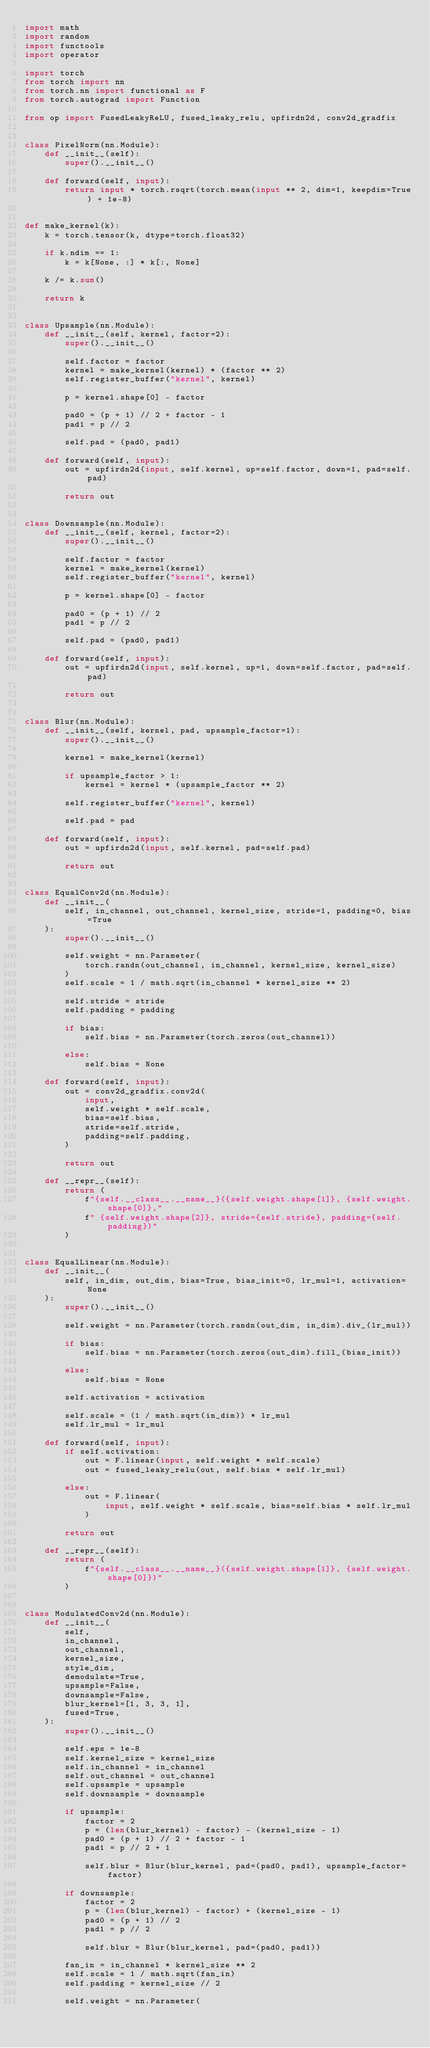<code> <loc_0><loc_0><loc_500><loc_500><_Python_>import math
import random
import functools
import operator

import torch
from torch import nn
from torch.nn import functional as F
from torch.autograd import Function

from op import FusedLeakyReLU, fused_leaky_relu, upfirdn2d, conv2d_gradfix


class PixelNorm(nn.Module):
    def __init__(self):
        super().__init__()

    def forward(self, input):
        return input * torch.rsqrt(torch.mean(input ** 2, dim=1, keepdim=True) + 1e-8)


def make_kernel(k):
    k = torch.tensor(k, dtype=torch.float32)

    if k.ndim == 1:
        k = k[None, :] * k[:, None]

    k /= k.sum()

    return k


class Upsample(nn.Module):
    def __init__(self, kernel, factor=2):
        super().__init__()

        self.factor = factor
        kernel = make_kernel(kernel) * (factor ** 2)
        self.register_buffer("kernel", kernel)

        p = kernel.shape[0] - factor

        pad0 = (p + 1) // 2 + factor - 1
        pad1 = p // 2

        self.pad = (pad0, pad1)

    def forward(self, input):
        out = upfirdn2d(input, self.kernel, up=self.factor, down=1, pad=self.pad)

        return out


class Downsample(nn.Module):
    def __init__(self, kernel, factor=2):
        super().__init__()

        self.factor = factor
        kernel = make_kernel(kernel)
        self.register_buffer("kernel", kernel)

        p = kernel.shape[0] - factor

        pad0 = (p + 1) // 2
        pad1 = p // 2

        self.pad = (pad0, pad1)

    def forward(self, input):
        out = upfirdn2d(input, self.kernel, up=1, down=self.factor, pad=self.pad)

        return out


class Blur(nn.Module):
    def __init__(self, kernel, pad, upsample_factor=1):
        super().__init__()

        kernel = make_kernel(kernel)

        if upsample_factor > 1:
            kernel = kernel * (upsample_factor ** 2)

        self.register_buffer("kernel", kernel)

        self.pad = pad

    def forward(self, input):
        out = upfirdn2d(input, self.kernel, pad=self.pad)

        return out


class EqualConv2d(nn.Module):
    def __init__(
        self, in_channel, out_channel, kernel_size, stride=1, padding=0, bias=True
    ):
        super().__init__()

        self.weight = nn.Parameter(
            torch.randn(out_channel, in_channel, kernel_size, kernel_size)
        )
        self.scale = 1 / math.sqrt(in_channel * kernel_size ** 2)

        self.stride = stride
        self.padding = padding

        if bias:
            self.bias = nn.Parameter(torch.zeros(out_channel))

        else:
            self.bias = None

    def forward(self, input):
        out = conv2d_gradfix.conv2d(
            input,
            self.weight * self.scale,
            bias=self.bias,
            stride=self.stride,
            padding=self.padding,
        )

        return out

    def __repr__(self):
        return (
            f"{self.__class__.__name__}({self.weight.shape[1]}, {self.weight.shape[0]},"
            f" {self.weight.shape[2]}, stride={self.stride}, padding={self.padding})"
        )


class EqualLinear(nn.Module):
    def __init__(
        self, in_dim, out_dim, bias=True, bias_init=0, lr_mul=1, activation=None
    ):
        super().__init__()

        self.weight = nn.Parameter(torch.randn(out_dim, in_dim).div_(lr_mul))

        if bias:
            self.bias = nn.Parameter(torch.zeros(out_dim).fill_(bias_init))

        else:
            self.bias = None

        self.activation = activation

        self.scale = (1 / math.sqrt(in_dim)) * lr_mul
        self.lr_mul = lr_mul

    def forward(self, input):
        if self.activation:
            out = F.linear(input, self.weight * self.scale)
            out = fused_leaky_relu(out, self.bias * self.lr_mul)

        else:
            out = F.linear(
                input, self.weight * self.scale, bias=self.bias * self.lr_mul
            )

        return out

    def __repr__(self):
        return (
            f"{self.__class__.__name__}({self.weight.shape[1]}, {self.weight.shape[0]})"
        )


class ModulatedConv2d(nn.Module):
    def __init__(
        self,
        in_channel,
        out_channel,
        kernel_size,
        style_dim,
        demodulate=True,
        upsample=False,
        downsample=False,
        blur_kernel=[1, 3, 3, 1],
        fused=True,
    ):
        super().__init__()

        self.eps = 1e-8
        self.kernel_size = kernel_size
        self.in_channel = in_channel
        self.out_channel = out_channel
        self.upsample = upsample
        self.downsample = downsample

        if upsample:
            factor = 2
            p = (len(blur_kernel) - factor) - (kernel_size - 1)
            pad0 = (p + 1) // 2 + factor - 1
            pad1 = p // 2 + 1

            self.blur = Blur(blur_kernel, pad=(pad0, pad1), upsample_factor=factor)

        if downsample:
            factor = 2
            p = (len(blur_kernel) - factor) + (kernel_size - 1)
            pad0 = (p + 1) // 2
            pad1 = p // 2

            self.blur = Blur(blur_kernel, pad=(pad0, pad1))

        fan_in = in_channel * kernel_size ** 2
        self.scale = 1 / math.sqrt(fan_in)
        self.padding = kernel_size // 2

        self.weight = nn.Parameter(</code> 